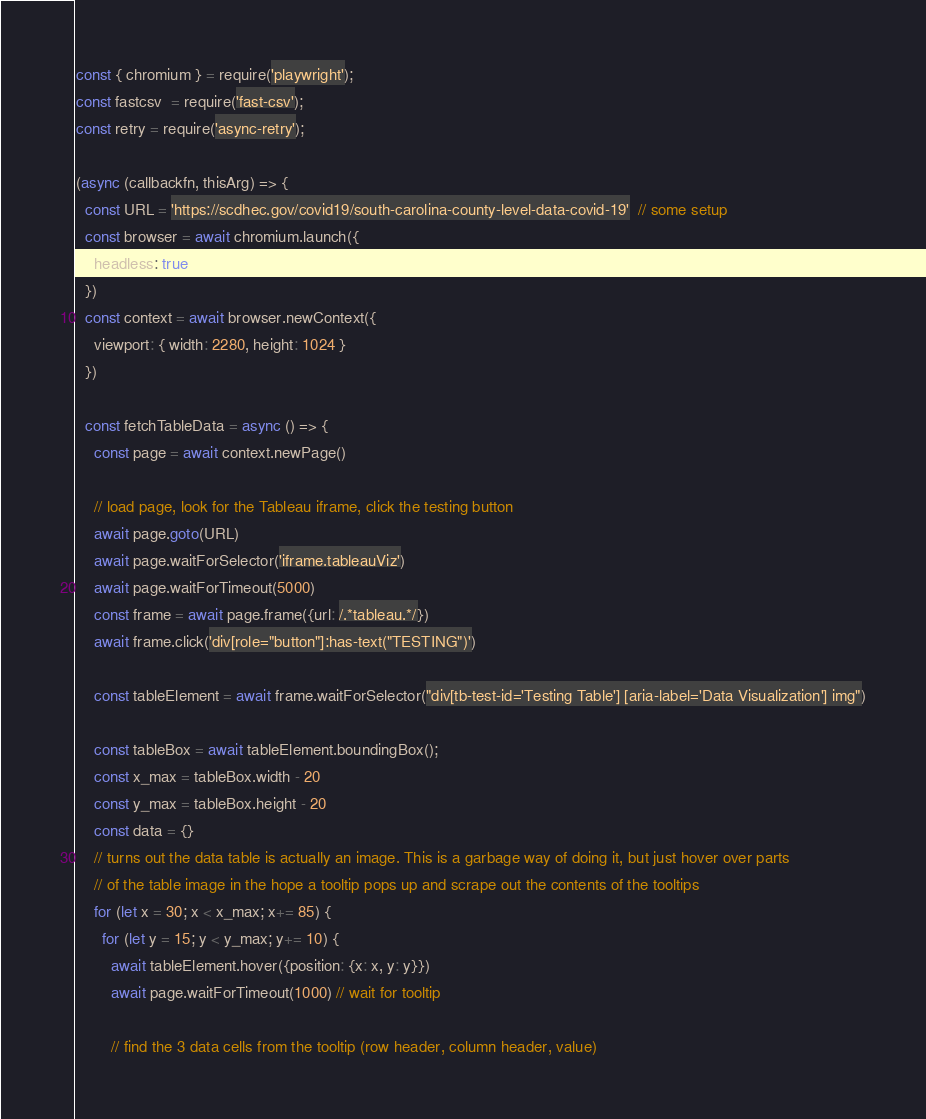<code> <loc_0><loc_0><loc_500><loc_500><_JavaScript_>const { chromium } = require('playwright');
const fastcsv  = require('fast-csv');
const retry = require('async-retry');

(async (callbackfn, thisArg) => {
  const URL = 'https://scdhec.gov/covid19/south-carolina-county-level-data-covid-19'  // some setup
  const browser = await chromium.launch({
    headless: true
  })
  const context = await browser.newContext({
    viewport: { width: 2280, height: 1024 }
  })

  const fetchTableData = async () => {
    const page = await context.newPage()

    // load page, look for the Tableau iframe, click the testing button
    await page.goto(URL)
    await page.waitForSelector('iframe.tableauViz')
    await page.waitForTimeout(5000)
    const frame = await page.frame({url: /.*tableau.*/})
    await frame.click('div[role="button"]:has-text("TESTING")')

    const tableElement = await frame.waitForSelector("div[tb-test-id='Testing Table'] [aria-label='Data Visualization'] img")

    const tableBox = await tableElement.boundingBox();
    const x_max = tableBox.width - 20
    const y_max = tableBox.height - 20
    const data = {}
    // turns out the data table is actually an image. This is a garbage way of doing it, but just hover over parts
    // of the table image in the hope a tooltip pops up and scrape out the contents of the tooltips
    for (let x = 30; x < x_max; x+= 85) {
      for (let y = 15; y < y_max; y+= 10) {
        await tableElement.hover({position: {x: x, y: y}})
        await page.waitForTimeout(1000) // wait for tooltip

        // find the 3 data cells from the tooltip (row header, column header, value)</code> 